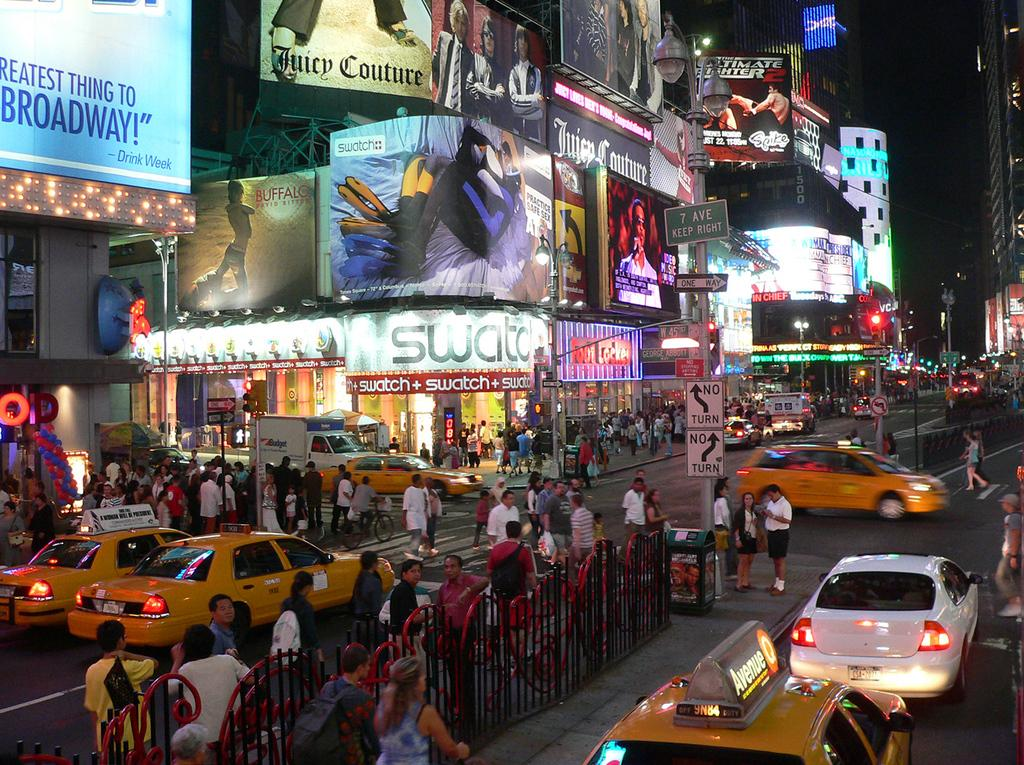<image>
Summarize the visual content of the image. A busy intersection in a city with a 7 Ave sign marking the street. 